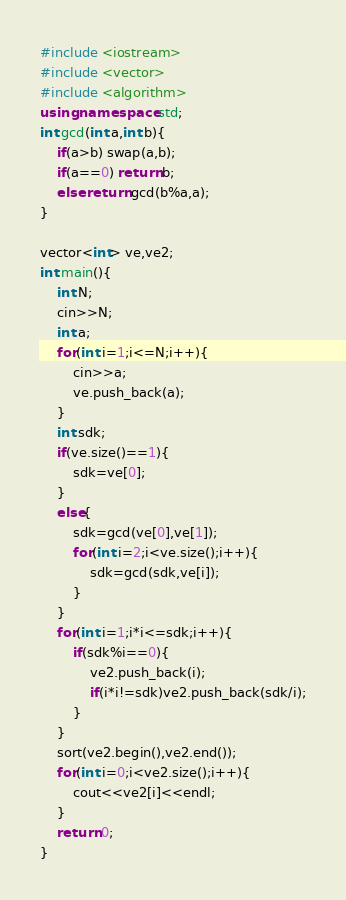Convert code to text. <code><loc_0><loc_0><loc_500><loc_500><_C++_>#include <iostream>
#include <vector>
#include <algorithm>
using namespace std;
int gcd(int a,int b){
	if(a>b) swap(a,b);
	if(a==0) return b;
	else return gcd(b%a,a);
}

vector<int> ve,ve2;
int main(){
	int N;
	cin>>N;
	int a;
	for(int i=1;i<=N;i++){
		cin>>a;
		ve.push_back(a);
	}
	int sdk;
	if(ve.size()==1){
		sdk=ve[0];
	}
	else{
		sdk=gcd(ve[0],ve[1]);
		for(int i=2;i<ve.size();i++){
			sdk=gcd(sdk,ve[i]);
		}
	}
	for(int i=1;i*i<=sdk;i++){
		if(sdk%i==0){
			ve2.push_back(i);
			if(i*i!=sdk)ve2.push_back(sdk/i);
		}
	}
	sort(ve2.begin(),ve2.end());
	for(int i=0;i<ve2.size();i++){
		cout<<ve2[i]<<endl;
	}
	return 0;
}</code> 